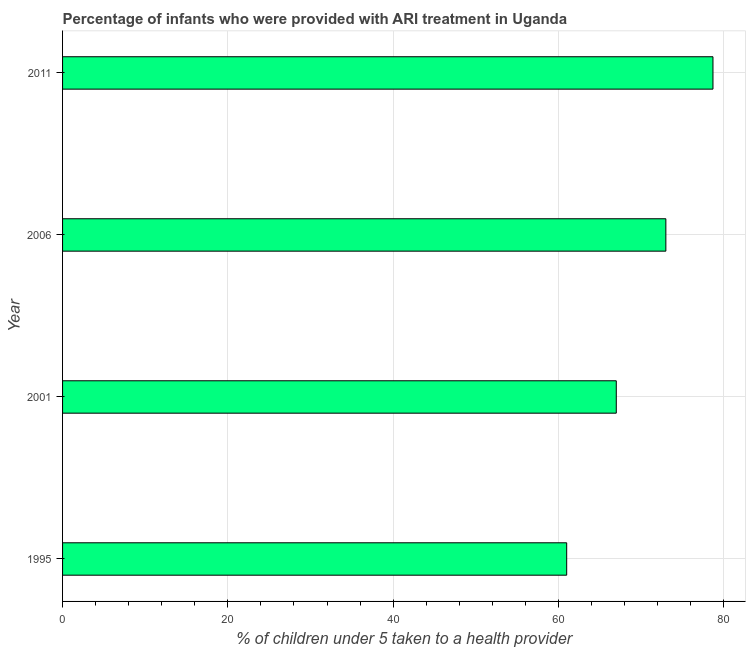What is the title of the graph?
Your answer should be very brief. Percentage of infants who were provided with ARI treatment in Uganda. What is the label or title of the X-axis?
Your answer should be very brief. % of children under 5 taken to a health provider. What is the label or title of the Y-axis?
Ensure brevity in your answer.  Year. What is the percentage of children who were provided with ari treatment in 2006?
Provide a succinct answer. 73. Across all years, what is the maximum percentage of children who were provided with ari treatment?
Offer a very short reply. 78.7. Across all years, what is the minimum percentage of children who were provided with ari treatment?
Give a very brief answer. 61. What is the sum of the percentage of children who were provided with ari treatment?
Make the answer very short. 279.7. What is the difference between the percentage of children who were provided with ari treatment in 2001 and 2006?
Your response must be concise. -6. What is the average percentage of children who were provided with ari treatment per year?
Your answer should be very brief. 69.92. Do a majority of the years between 2006 and 1995 (inclusive) have percentage of children who were provided with ari treatment greater than 72 %?
Ensure brevity in your answer.  Yes. What is the ratio of the percentage of children who were provided with ari treatment in 1995 to that in 2001?
Provide a short and direct response. 0.91. Is the percentage of children who were provided with ari treatment in 2001 less than that in 2011?
Offer a very short reply. Yes. What is the difference between the highest and the second highest percentage of children who were provided with ari treatment?
Offer a very short reply. 5.7. In how many years, is the percentage of children who were provided with ari treatment greater than the average percentage of children who were provided with ari treatment taken over all years?
Your answer should be very brief. 2. How many years are there in the graph?
Provide a short and direct response. 4. What is the difference between two consecutive major ticks on the X-axis?
Offer a very short reply. 20. What is the % of children under 5 taken to a health provider in 2006?
Provide a short and direct response. 73. What is the % of children under 5 taken to a health provider in 2011?
Your response must be concise. 78.7. What is the difference between the % of children under 5 taken to a health provider in 1995 and 2011?
Make the answer very short. -17.7. What is the ratio of the % of children under 5 taken to a health provider in 1995 to that in 2001?
Your response must be concise. 0.91. What is the ratio of the % of children under 5 taken to a health provider in 1995 to that in 2006?
Your answer should be very brief. 0.84. What is the ratio of the % of children under 5 taken to a health provider in 1995 to that in 2011?
Provide a succinct answer. 0.78. What is the ratio of the % of children under 5 taken to a health provider in 2001 to that in 2006?
Make the answer very short. 0.92. What is the ratio of the % of children under 5 taken to a health provider in 2001 to that in 2011?
Make the answer very short. 0.85. What is the ratio of the % of children under 5 taken to a health provider in 2006 to that in 2011?
Provide a short and direct response. 0.93. 